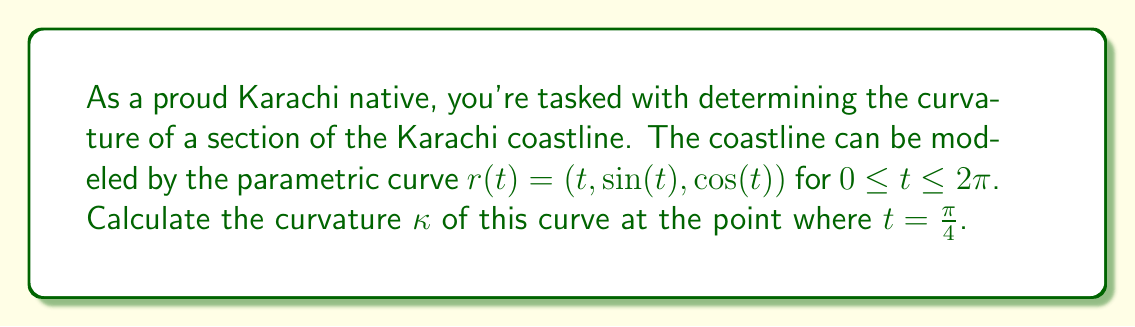Can you solve this math problem? Let's approach this step-by-step:

1) The curvature $\kappa$ of a parametric curve $r(t)$ is given by:

   $$\kappa = \frac{|\dot{r}(t) \times \ddot{r}(t)|}{|\dot{r}(t)|^3}$$

2) First, we need to find $\dot{r}(t)$ and $\ddot{r}(t)$:
   
   $\dot{r}(t) = (1, \cos(t), -\sin(t))$
   $\ddot{r}(t) = (0, -\sin(t), -\cos(t))$

3) Now, let's calculate $\dot{r}(t) \times \ddot{r}(t)$:

   $$\begin{vmatrix} 
   i & j & k \\
   1 & \cos(t) & -\sin(t) \\
   0 & -\sin(t) & -\cos(t)
   \end{vmatrix}
   = (-\cos^2(t) - \sin^2(t), -\sin(t), \cos(t))$$

   $= (-1, -\sin(t), \cos(t))$

4) The magnitude of this cross product is:

   $|\dot{r}(t) \times \ddot{r}(t)| = \sqrt{1 + \sin^2(t) + \cos^2(t)} = \sqrt{2}$

5) Next, we need $|\dot{r}(t)|$:

   $|\dot{r}(t)| = \sqrt{1 + \cos^2(t) + \sin^2(t)} = \sqrt{2}$

6) Now we can substitute these into our curvature formula:

   $$\kappa = \frac{\sqrt{2}}{(\sqrt{2})^3} = \frac{1}{2}$$

7) This result is constant for all $t$, including $t = \frac{\pi}{4}$.
Answer: $\kappa = \frac{1}{2}$ 